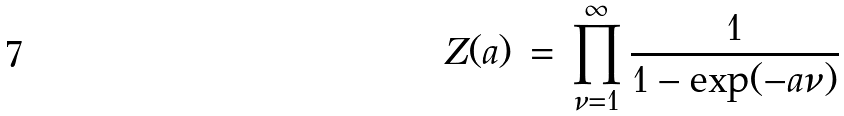Convert formula to latex. <formula><loc_0><loc_0><loc_500><loc_500>Z ( a ) \, = \, \prod _ { \nu = 1 } ^ { \infty } \frac { 1 } { 1 - \exp ( - a \nu ) }</formula> 